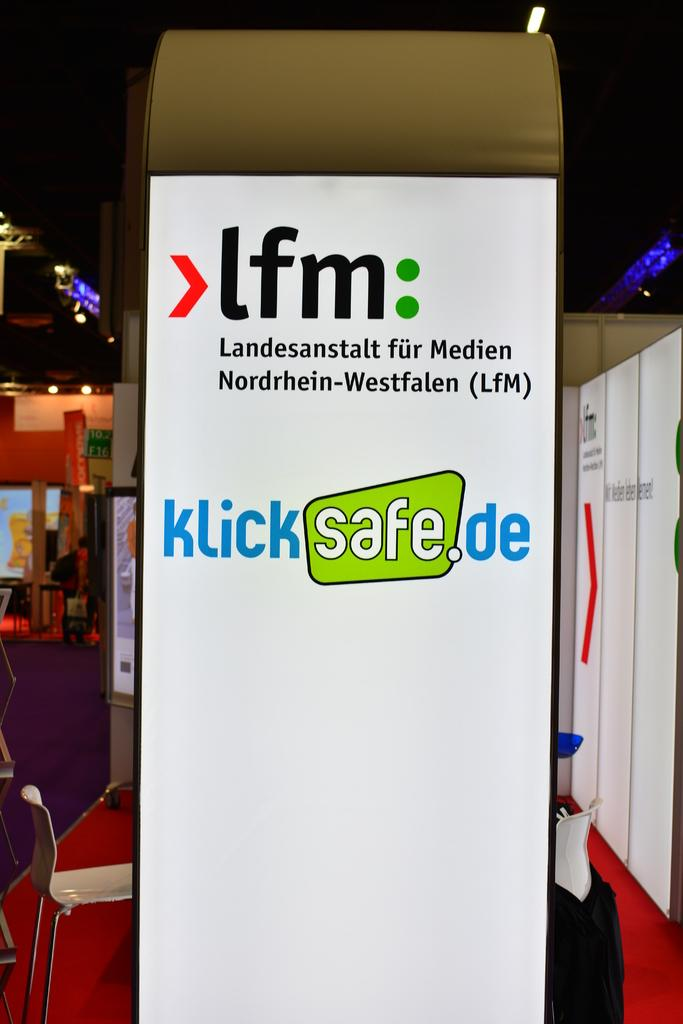<image>
Share a concise interpretation of the image provided. A sign for LfM shows a url that reads kliksafe.de, and the safe is in a green box. 